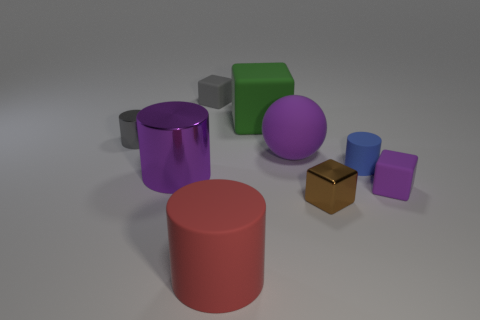Subtract all red cubes. Subtract all brown spheres. How many cubes are left? 4 Subtract all cylinders. How many objects are left? 5 Add 1 green blocks. How many objects exist? 10 Add 2 metallic objects. How many metallic objects are left? 5 Add 3 gray cubes. How many gray cubes exist? 4 Subtract 0 red cubes. How many objects are left? 9 Subtract all red cylinders. Subtract all gray things. How many objects are left? 6 